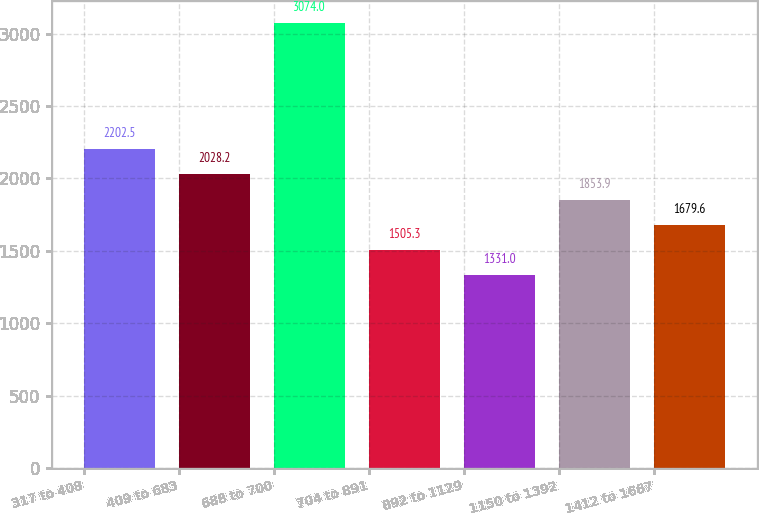Convert chart to OTSL. <chart><loc_0><loc_0><loc_500><loc_500><bar_chart><fcel>317 to 408<fcel>409 to 683<fcel>688 to 700<fcel>704 to 891<fcel>892 to 1129<fcel>1150 to 1392<fcel>1412 to 1667<nl><fcel>2202.5<fcel>2028.2<fcel>3074<fcel>1505.3<fcel>1331<fcel>1853.9<fcel>1679.6<nl></chart> 